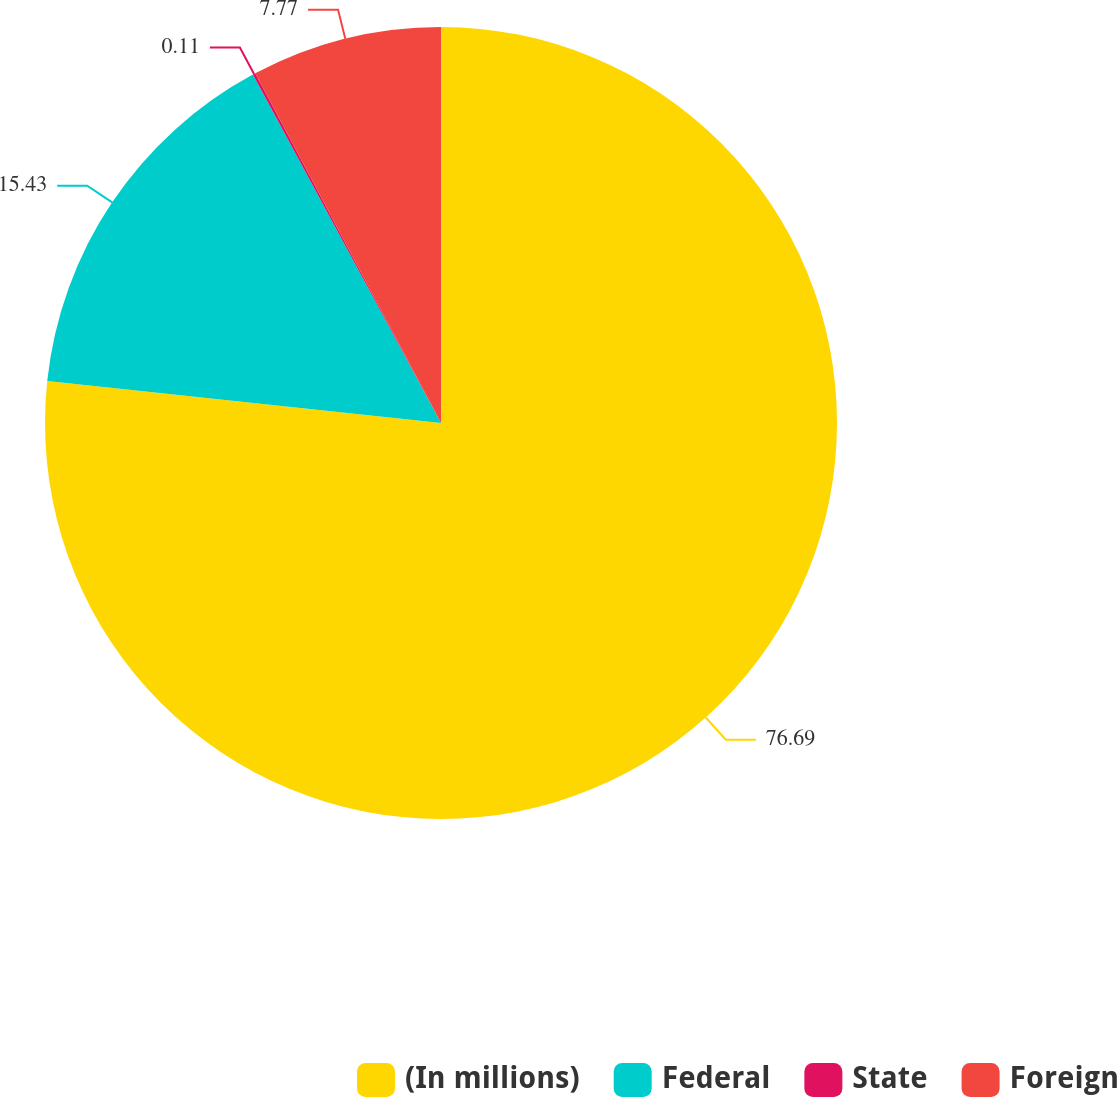Convert chart. <chart><loc_0><loc_0><loc_500><loc_500><pie_chart><fcel>(In millions)<fcel>Federal<fcel>State<fcel>Foreign<nl><fcel>76.69%<fcel>15.43%<fcel>0.11%<fcel>7.77%<nl></chart> 